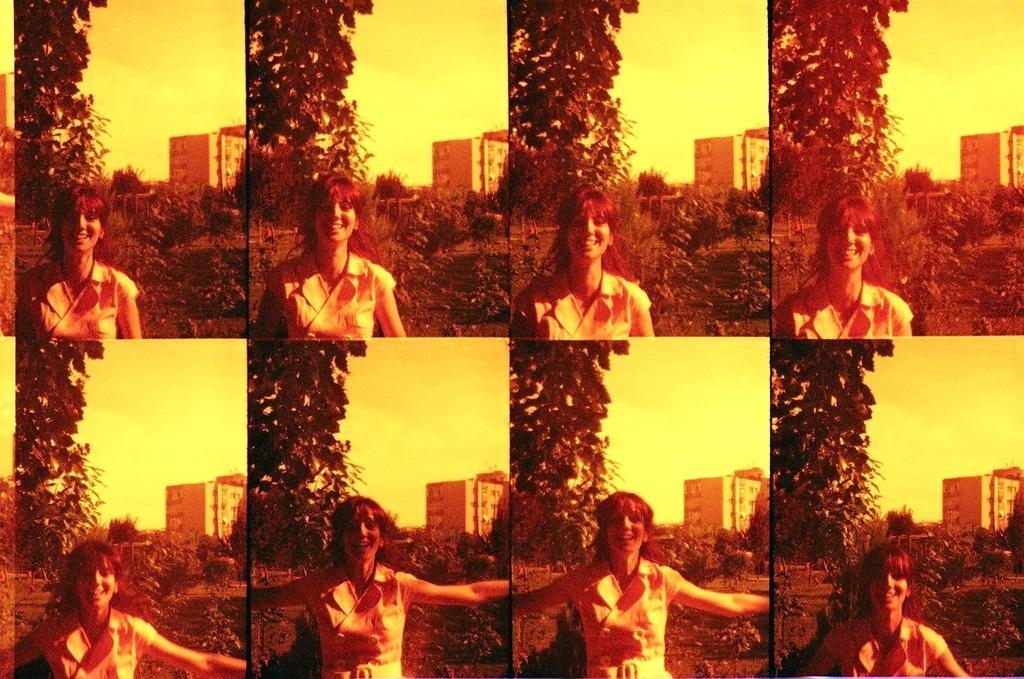Please provide a concise description of this image. The picture is collage of images. In this picture we can see a woman with a smiley face. In this picture in every image there are plants, trees, buildings and sky. 